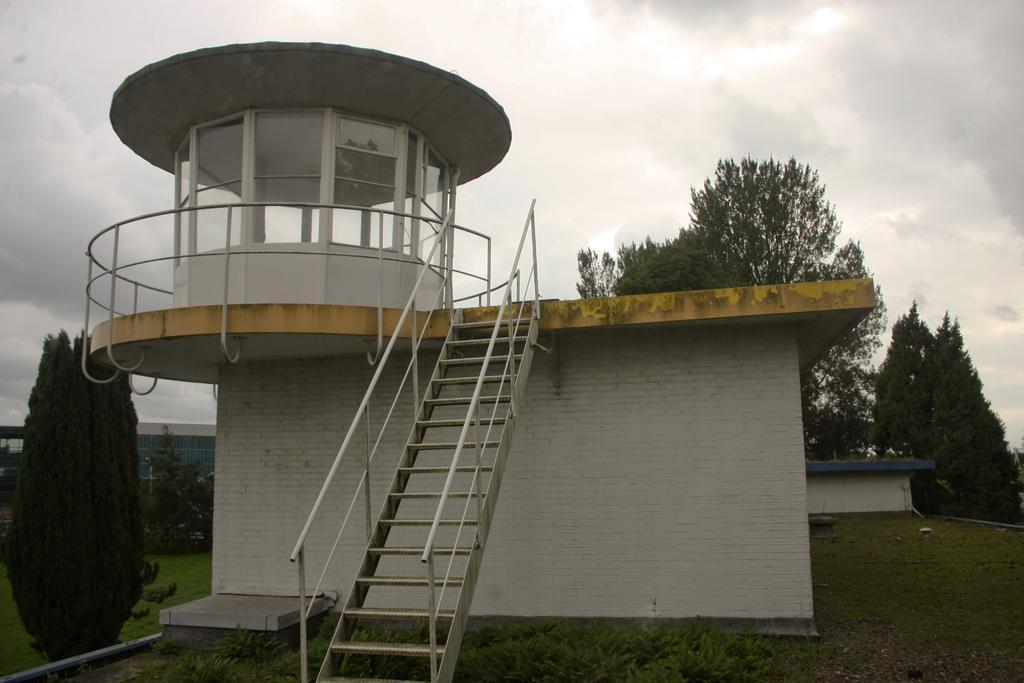In one or two sentences, can you explain what this image depicts? This is an outside view. Here I can see a building. In front of this, I can see the stairs. At the bottom there are many plants and grass on the ground. In the background, I can see the trees. On the left side there is a building. At the top of the image, I can see the sky and clouds. 